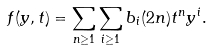<formula> <loc_0><loc_0><loc_500><loc_500>f ( y , t ) = \sum _ { n \geq 1 } \sum _ { i \geq 1 } b _ { i } ( 2 n ) t ^ { n } y ^ { i } .</formula> 